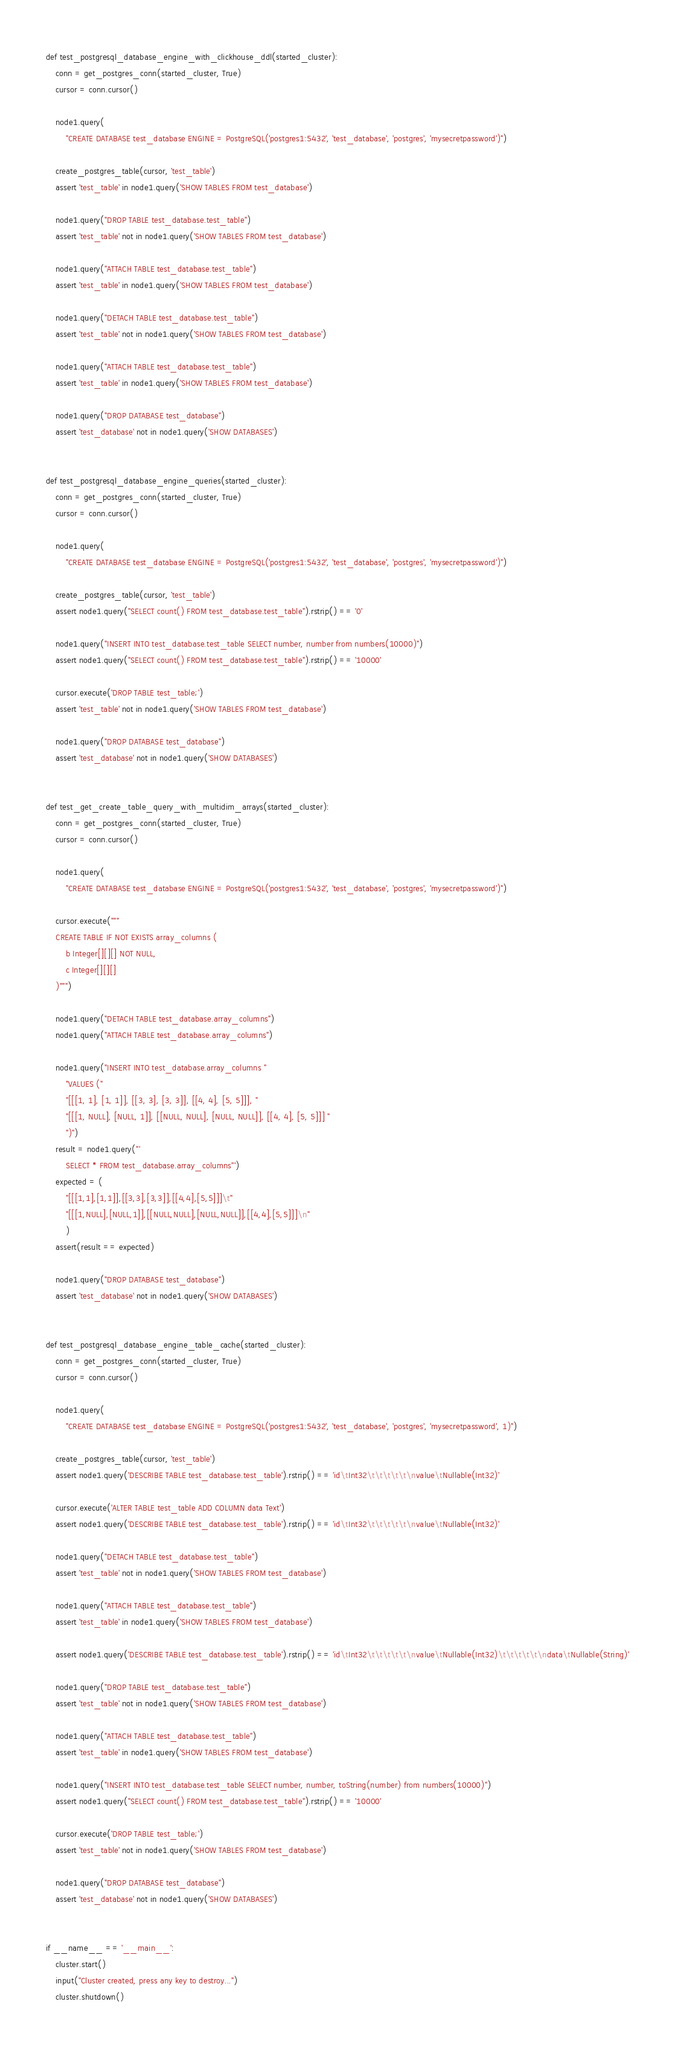Convert code to text. <code><loc_0><loc_0><loc_500><loc_500><_Python_>def test_postgresql_database_engine_with_clickhouse_ddl(started_cluster):
    conn = get_postgres_conn(started_cluster, True)
    cursor = conn.cursor()

    node1.query(
        "CREATE DATABASE test_database ENGINE = PostgreSQL('postgres1:5432', 'test_database', 'postgres', 'mysecretpassword')")

    create_postgres_table(cursor, 'test_table')
    assert 'test_table' in node1.query('SHOW TABLES FROM test_database')

    node1.query("DROP TABLE test_database.test_table")
    assert 'test_table' not in node1.query('SHOW TABLES FROM test_database')

    node1.query("ATTACH TABLE test_database.test_table")
    assert 'test_table' in node1.query('SHOW TABLES FROM test_database')

    node1.query("DETACH TABLE test_database.test_table")
    assert 'test_table' not in node1.query('SHOW TABLES FROM test_database')

    node1.query("ATTACH TABLE test_database.test_table")
    assert 'test_table' in node1.query('SHOW TABLES FROM test_database')

    node1.query("DROP DATABASE test_database")
    assert 'test_database' not in node1.query('SHOW DATABASES')


def test_postgresql_database_engine_queries(started_cluster):
    conn = get_postgres_conn(started_cluster, True)
    cursor = conn.cursor()

    node1.query(
        "CREATE DATABASE test_database ENGINE = PostgreSQL('postgres1:5432', 'test_database', 'postgres', 'mysecretpassword')")

    create_postgres_table(cursor, 'test_table')
    assert node1.query("SELECT count() FROM test_database.test_table").rstrip() == '0'

    node1.query("INSERT INTO test_database.test_table SELECT number, number from numbers(10000)")
    assert node1.query("SELECT count() FROM test_database.test_table").rstrip() == '10000'

    cursor.execute('DROP TABLE test_table;')
    assert 'test_table' not in node1.query('SHOW TABLES FROM test_database')

    node1.query("DROP DATABASE test_database")
    assert 'test_database' not in node1.query('SHOW DATABASES')


def test_get_create_table_query_with_multidim_arrays(started_cluster):
    conn = get_postgres_conn(started_cluster, True)
    cursor = conn.cursor()

    node1.query(
        "CREATE DATABASE test_database ENGINE = PostgreSQL('postgres1:5432', 'test_database', 'postgres', 'mysecretpassword')")

    cursor.execute("""
    CREATE TABLE IF NOT EXISTS array_columns (
        b Integer[][][] NOT NULL,
        c Integer[][][]
    )""")

    node1.query("DETACH TABLE test_database.array_columns")
    node1.query("ATTACH TABLE test_database.array_columns")

    node1.query("INSERT INTO test_database.array_columns "
        "VALUES ("
        "[[[1, 1], [1, 1]], [[3, 3], [3, 3]], [[4, 4], [5, 5]]], "
        "[[[1, NULL], [NULL, 1]], [[NULL, NULL], [NULL, NULL]], [[4, 4], [5, 5]]] "
        ")")
    result = node1.query('''
        SELECT * FROM test_database.array_columns''')
    expected = (
        "[[[1,1],[1,1]],[[3,3],[3,3]],[[4,4],[5,5]]]\t"
        "[[[1,NULL],[NULL,1]],[[NULL,NULL],[NULL,NULL]],[[4,4],[5,5]]]\n"
        )
    assert(result == expected)

    node1.query("DROP DATABASE test_database")
    assert 'test_database' not in node1.query('SHOW DATABASES')


def test_postgresql_database_engine_table_cache(started_cluster):
    conn = get_postgres_conn(started_cluster, True)
    cursor = conn.cursor()

    node1.query(
        "CREATE DATABASE test_database ENGINE = PostgreSQL('postgres1:5432', 'test_database', 'postgres', 'mysecretpassword', 1)")

    create_postgres_table(cursor, 'test_table')
    assert node1.query('DESCRIBE TABLE test_database.test_table').rstrip() == 'id\tInt32\t\t\t\t\t\nvalue\tNullable(Int32)'

    cursor.execute('ALTER TABLE test_table ADD COLUMN data Text')
    assert node1.query('DESCRIBE TABLE test_database.test_table').rstrip() == 'id\tInt32\t\t\t\t\t\nvalue\tNullable(Int32)'

    node1.query("DETACH TABLE test_database.test_table")
    assert 'test_table' not in node1.query('SHOW TABLES FROM test_database')

    node1.query("ATTACH TABLE test_database.test_table")
    assert 'test_table' in node1.query('SHOW TABLES FROM test_database')

    assert node1.query('DESCRIBE TABLE test_database.test_table').rstrip() == 'id\tInt32\t\t\t\t\t\nvalue\tNullable(Int32)\t\t\t\t\t\ndata\tNullable(String)'

    node1.query("DROP TABLE test_database.test_table")
    assert 'test_table' not in node1.query('SHOW TABLES FROM test_database')

    node1.query("ATTACH TABLE test_database.test_table")
    assert 'test_table' in node1.query('SHOW TABLES FROM test_database')

    node1.query("INSERT INTO test_database.test_table SELECT number, number, toString(number) from numbers(10000)")
    assert node1.query("SELECT count() FROM test_database.test_table").rstrip() == '10000'

    cursor.execute('DROP TABLE test_table;')
    assert 'test_table' not in node1.query('SHOW TABLES FROM test_database')

    node1.query("DROP DATABASE test_database")
    assert 'test_database' not in node1.query('SHOW DATABASES')


if __name__ == '__main__':
    cluster.start()
    input("Cluster created, press any key to destroy...")
    cluster.shutdown()
</code> 